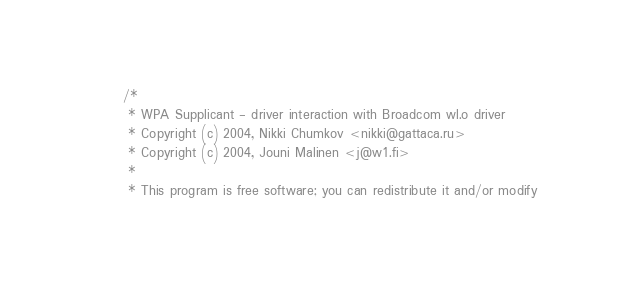Convert code to text. <code><loc_0><loc_0><loc_500><loc_500><_C_>/*
 * WPA Supplicant - driver interaction with Broadcom wl.o driver
 * Copyright (c) 2004, Nikki Chumkov <nikki@gattaca.ru>
 * Copyright (c) 2004, Jouni Malinen <j@w1.fi>
 *
 * This program is free software; you can redistribute it and/or modify</code> 